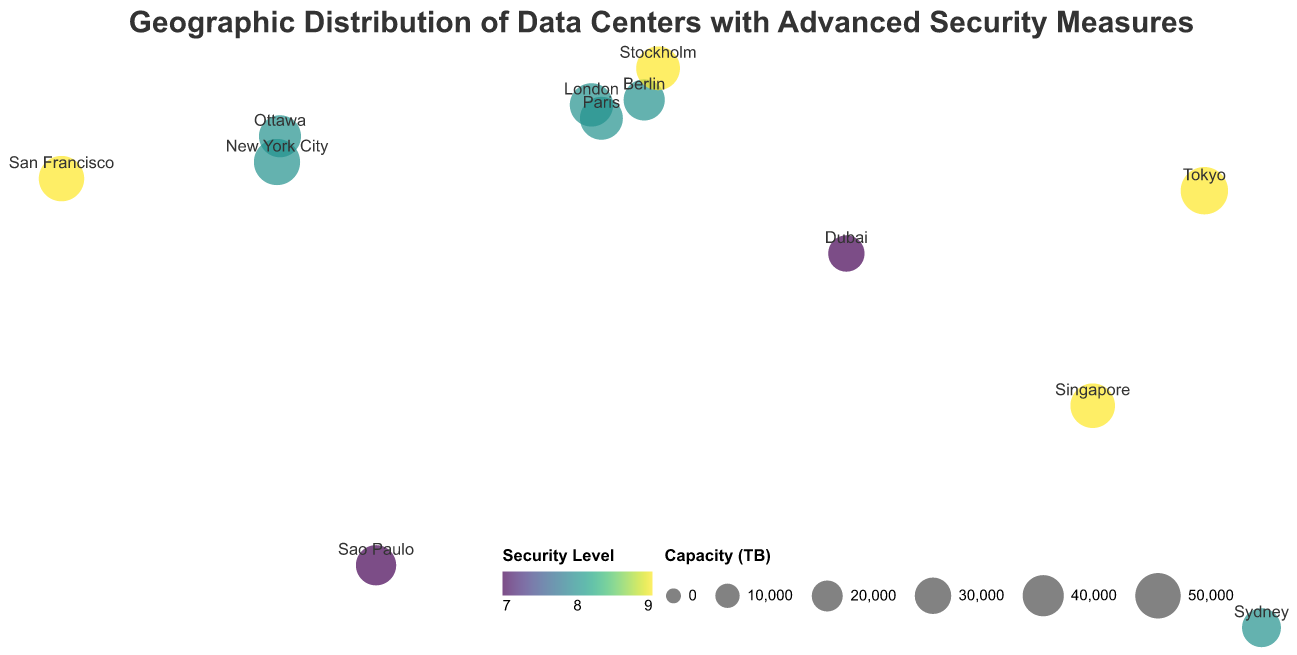What's the title of the figure? The title is located at the top of the figure and usually provides an overview of what the data represents. In this case, the title reads "Geographic Distribution of Data Centers with Advanced Security Measures."
Answer: Geographic Distribution of Data Centers with Advanced Security Measures Which city has the highest security level? To determine which city has the highest security level, look at the color legend corresponding to the "Security Level" attribute. San Francisco, Tokyo, Singapore, and Stockholm have the highest security level (9).
Answer: San Francisco, Tokyo, Singapore, Stockholm How many data centers have a security level of 8? Examine the color coding in the legend and identify the data centers corresponding to a security level of 8. The cities that match this criterion are London, Berlin, Sydney, Ottawa, New York City, and Paris. Count these cities.
Answer: 6 What is the total capacity of data centers in the USA? Find the two cities located in the USA, San Francisco and New York City. Sum their capacities: 50000 TB for San Francisco and 52000 TB for New York City. Thus, the total capacity is 50000 + 52000 = 102000 TB.
Answer: 102000 TB Which city in Europe has the highest capacity? Look at the European cities: London, Berlin, Stockholm, and Paris. Compare their capacities: London (45000 TB), Berlin (40000 TB), Stockholm (46000 TB), Paris (44000 TB). Stockholm has the highest capacity among European cities.
Answer: Stockholm Compare the security levels between Dubai and Sao Paulo. Which one is higher? Locate Dubai and Sao Paulo on the map and compare their security levels. Dubai has a security level of 7, while Sao Paulo also has a security level of 7. Since they are equal, neither is higher than the other.
Answer: Equal (both 7) What is the average security level of the data centers? To find the average security level, sum all the security levels and divide by the number of data centers: (9 + 8 + 9 + 8 + 8 + 7 + 9 + 8 + 7 + 9 + 8 + 8) = 98. Then, divide by the total number of data centers (12). Average security level = 98 / 12 ≈ 8.17.
Answer: 8.17 Which city has the smallest data center capacity? Identify the city with the smallest size indicator (capacity) on the map. Dubai has the smallest data center capacity at 30000 TB.
Answer: Dubai How does the security level of Singapore compare to that of New York City? Locate Singapore and New York City on the map and check their security levels. Singapore has a security level of 9, while New York City has a security level of 8. Therefore, Singapore has a higher security level.
Answer: Singapore What's the total number of data centers displayed in the figure? Count the total number of circles (data points) on the map. There are 12 data centers represented in the figure.
Answer: 12 